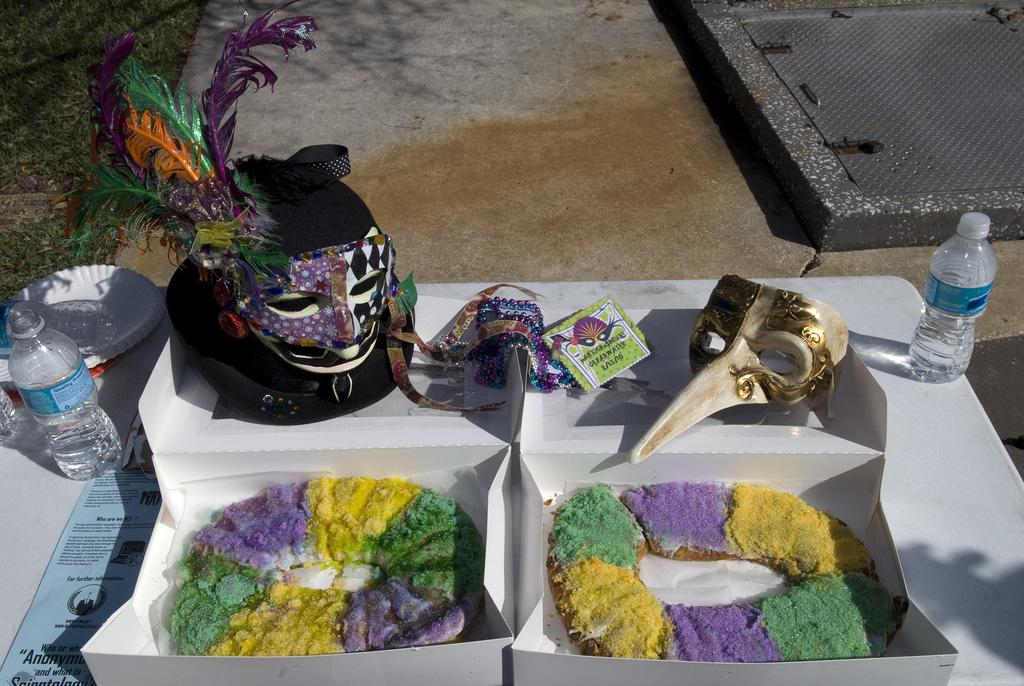What type of food is in the white box in the image? There are donuts in a white box in the image. What is located behind the donuts in the image? There are masks behind the donuts in the image. What can be seen at the right and left sides of the image? There are water bottles at the right and left sides of the image. Can you tell me how many toads are sitting on the water bottles in the image? There are no toads present in the image; it features donuts, masks, and water bottles. What type of lock is used to secure the white box in the image? There is no lock present on the white box in the image. 